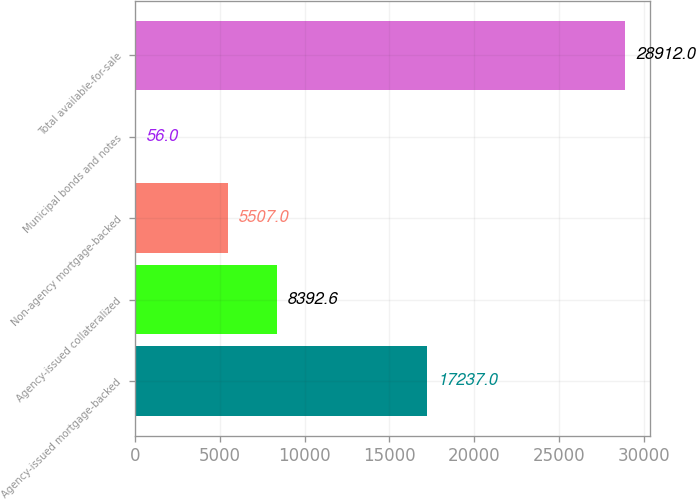<chart> <loc_0><loc_0><loc_500><loc_500><bar_chart><fcel>Agency-issued mortgage-backed<fcel>Agency-issued collateralized<fcel>Non-agency mortgage-backed<fcel>Municipal bonds and notes<fcel>Total available-for-sale<nl><fcel>17237<fcel>8392.6<fcel>5507<fcel>56<fcel>28912<nl></chart> 